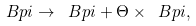Convert formula to latex. <formula><loc_0><loc_0><loc_500><loc_500>\ B p i \rightarrow \ B p i + \Theta \times \ B p i ,</formula> 